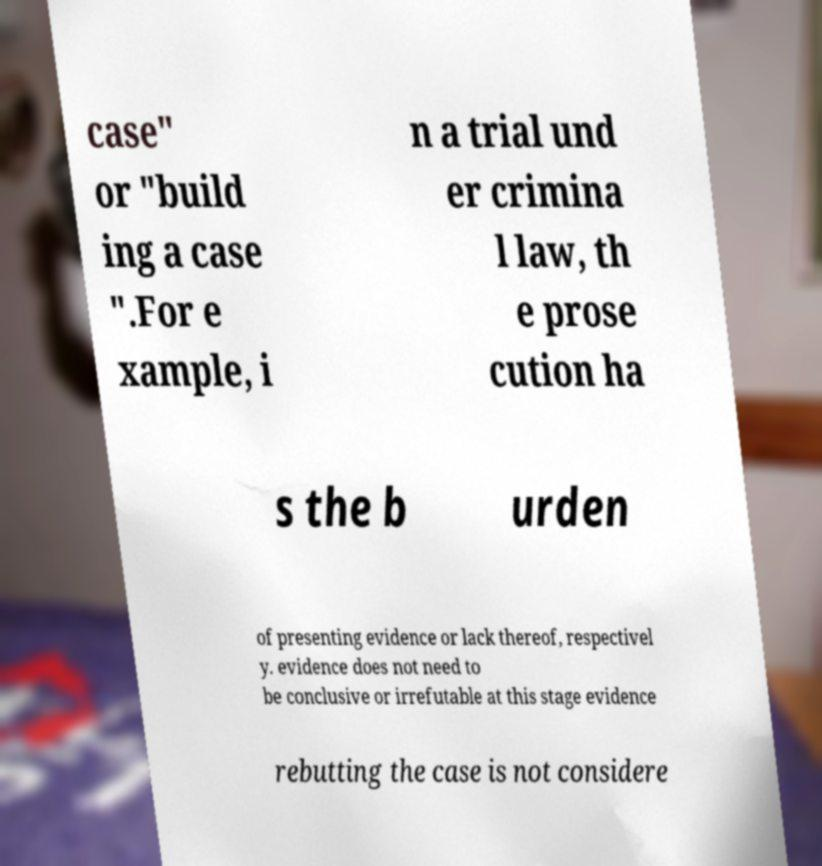I need the written content from this picture converted into text. Can you do that? case" or "build ing a case ".For e xample, i n a trial und er crimina l law, th e prose cution ha s the b urden of presenting evidence or lack thereof, respectivel y. evidence does not need to be conclusive or irrefutable at this stage evidence rebutting the case is not considere 